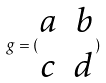Convert formula to latex. <formula><loc_0><loc_0><loc_500><loc_500>g = ( \begin{matrix} a & b \\ c & d \end{matrix} )</formula> 